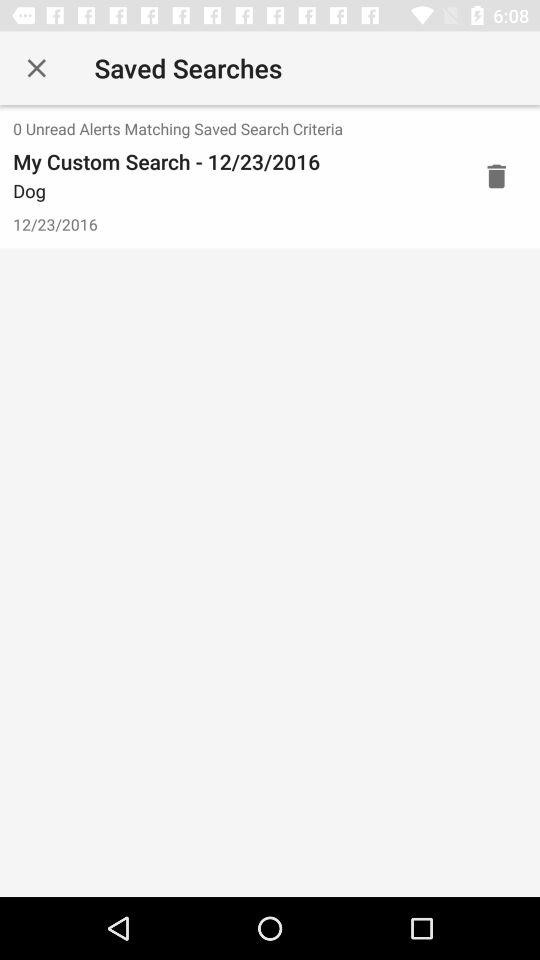How many alerts are there that match the saved search criteria?
Answer the question using a single word or phrase. 0 